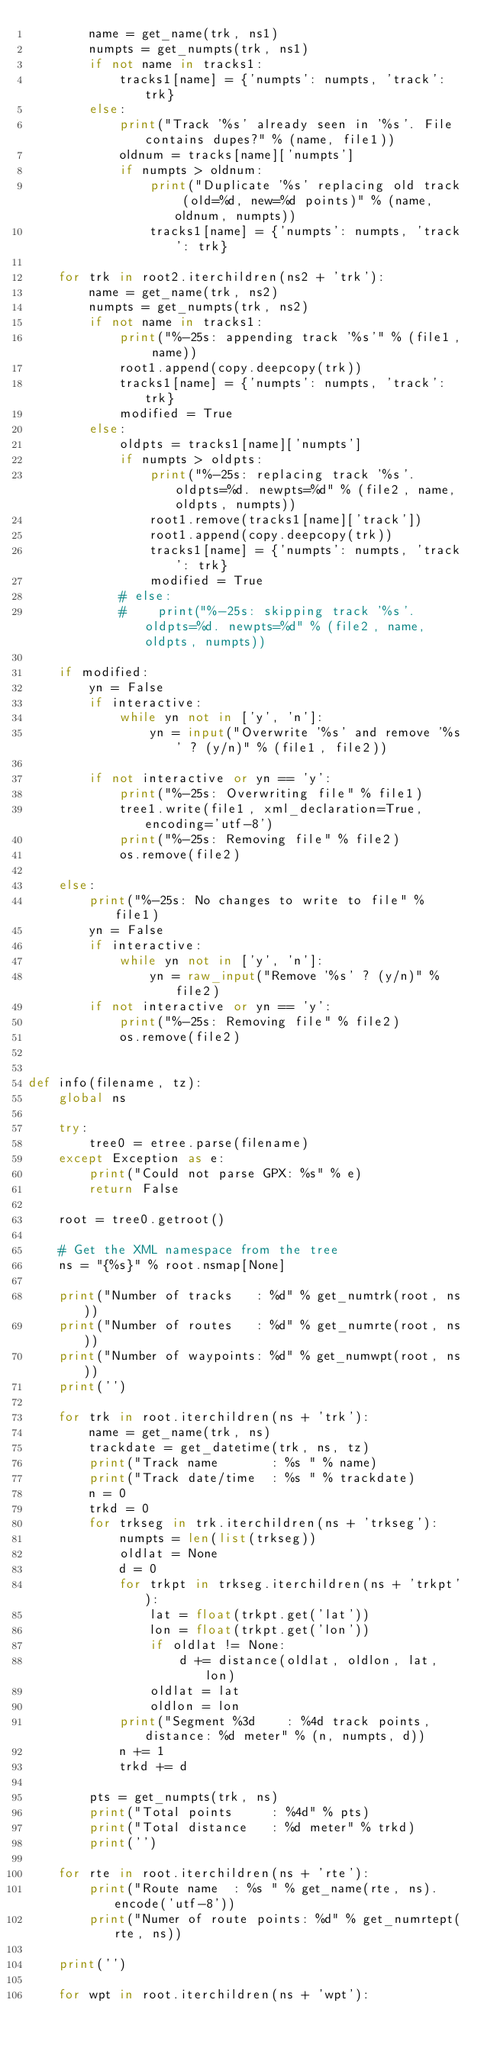<code> <loc_0><loc_0><loc_500><loc_500><_Python_>        name = get_name(trk, ns1)
        numpts = get_numpts(trk, ns1)
        if not name in tracks1:
            tracks1[name] = {'numpts': numpts, 'track': trk}
        else:
            print("Track '%s' already seen in '%s'. File contains dupes?" % (name, file1))
            oldnum = tracks[name]['numpts']
            if numpts > oldnum:
                print("Duplicate '%s' replacing old track (old=%d, new=%d points)" % (name, oldnum, numpts))
                tracks1[name] = {'numpts': numpts, 'track': trk}

    for trk in root2.iterchildren(ns2 + 'trk'):
        name = get_name(trk, ns2)
        numpts = get_numpts(trk, ns2)
        if not name in tracks1:
            print("%-25s: appending track '%s'" % (file1, name))
            root1.append(copy.deepcopy(trk))
            tracks1[name] = {'numpts': numpts, 'track': trk}
            modified = True
        else:
            oldpts = tracks1[name]['numpts']
            if numpts > oldpts:
                print("%-25s: replacing track '%s'. oldpts=%d. newpts=%d" % (file2, name, oldpts, numpts))
                root1.remove(tracks1[name]['track'])
                root1.append(copy.deepcopy(trk))
                tracks1[name] = {'numpts': numpts, 'track': trk}
                modified = True
            # else:
            #    print("%-25s: skipping track '%s'. oldpts=%d. newpts=%d" % (file2, name, oldpts, numpts))

    if modified:
        yn = False
        if interactive:
            while yn not in ['y', 'n']:
                yn = input("Overwrite '%s' and remove '%s' ? (y/n)" % (file1, file2))

        if not interactive or yn == 'y':
            print("%-25s: Overwriting file" % file1)
            tree1.write(file1, xml_declaration=True, encoding='utf-8')
            print("%-25s: Removing file" % file2)
            os.remove(file2)

    else:
        print("%-25s: No changes to write to file" % file1)
        yn = False
        if interactive:
            while yn not in ['y', 'n']:
                yn = raw_input("Remove '%s' ? (y/n)" % file2)
        if not interactive or yn == 'y':
            print("%-25s: Removing file" % file2)
            os.remove(file2)


def info(filename, tz):
    global ns

    try:
        tree0 = etree.parse(filename)
    except Exception as e:
        print("Could not parse GPX: %s" % e)
        return False

    root = tree0.getroot()

    # Get the XML namespace from the tree
    ns = "{%s}" % root.nsmap[None]

    print("Number of tracks   : %d" % get_numtrk(root, ns))
    print("Number of routes   : %d" % get_numrte(root, ns))
    print("Number of waypoints: %d" % get_numwpt(root, ns))
    print('')

    for trk in root.iterchildren(ns + 'trk'):
        name = get_name(trk, ns)
        trackdate = get_datetime(trk, ns, tz)
        print("Track name       : %s " % name)
        print("Track date/time  : %s " % trackdate)
        n = 0
        trkd = 0
        for trkseg in trk.iterchildren(ns + 'trkseg'):
            numpts = len(list(trkseg))
            oldlat = None
            d = 0
            for trkpt in trkseg.iterchildren(ns + 'trkpt'):
                lat = float(trkpt.get('lat'))
                lon = float(trkpt.get('lon'))
                if oldlat != None:
                    d += distance(oldlat, oldlon, lat, lon)
                oldlat = lat
                oldlon = lon
            print("Segment %3d    : %4d track points, distance: %d meter" % (n, numpts, d))
            n += 1
            trkd += d

        pts = get_numpts(trk, ns)
        print("Total points     : %4d" % pts)
        print("Total distance   : %d meter" % trkd)
        print('')

    for rte in root.iterchildren(ns + 'rte'):
        print("Route name  : %s " % get_name(rte, ns).encode('utf-8'))
        print("Numer of route points: %d" % get_numrtept(rte, ns))

    print('')

    for wpt in root.iterchildren(ns + 'wpt'):</code> 